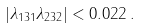Convert formula to latex. <formula><loc_0><loc_0><loc_500><loc_500>| \lambda _ { 1 3 1 } \lambda _ { 2 3 2 } | < 0 . 0 2 2 \, .</formula> 